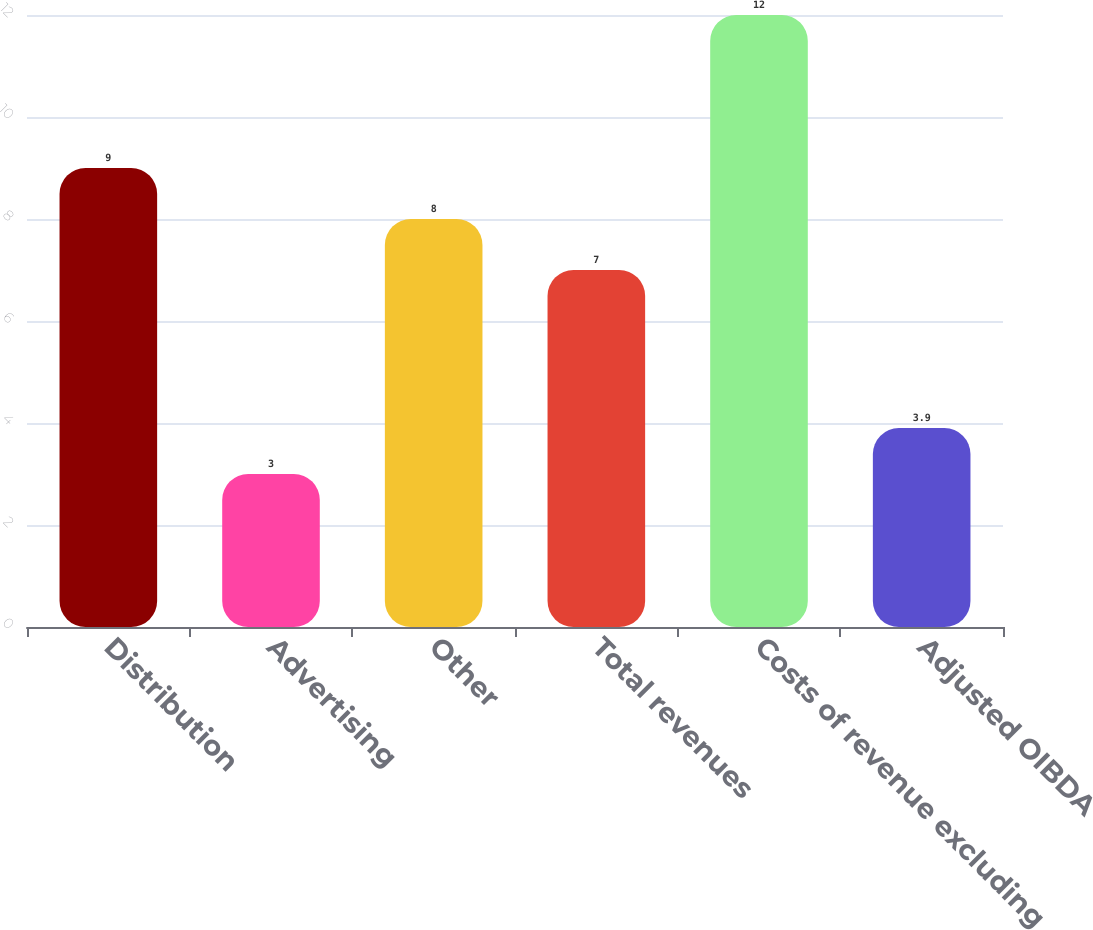Convert chart to OTSL. <chart><loc_0><loc_0><loc_500><loc_500><bar_chart><fcel>Distribution<fcel>Advertising<fcel>Other<fcel>Total revenues<fcel>Costs of revenue excluding<fcel>Adjusted OIBDA<nl><fcel>9<fcel>3<fcel>8<fcel>7<fcel>12<fcel>3.9<nl></chart> 